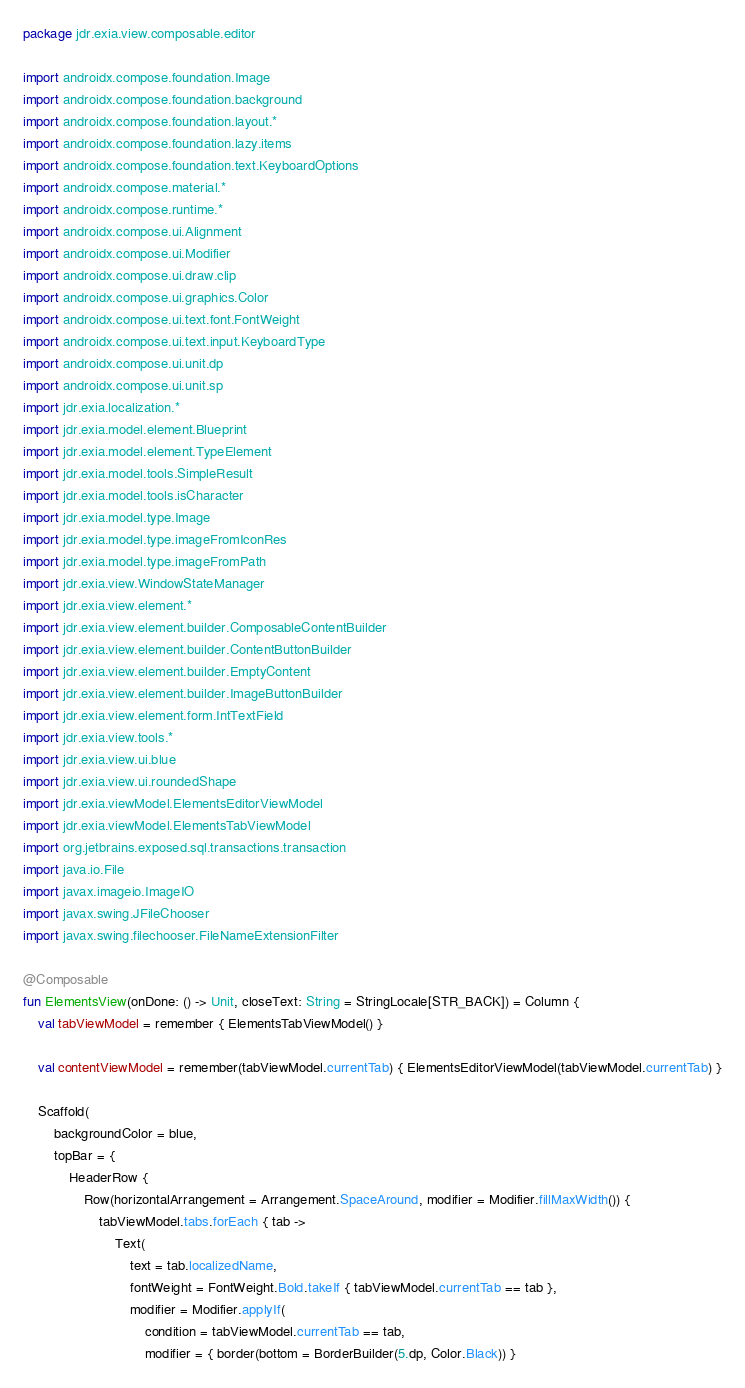<code> <loc_0><loc_0><loc_500><loc_500><_Kotlin_>package jdr.exia.view.composable.editor

import androidx.compose.foundation.Image
import androidx.compose.foundation.background
import androidx.compose.foundation.layout.*
import androidx.compose.foundation.lazy.items
import androidx.compose.foundation.text.KeyboardOptions
import androidx.compose.material.*
import androidx.compose.runtime.*
import androidx.compose.ui.Alignment
import androidx.compose.ui.Modifier
import androidx.compose.ui.draw.clip
import androidx.compose.ui.graphics.Color
import androidx.compose.ui.text.font.FontWeight
import androidx.compose.ui.text.input.KeyboardType
import androidx.compose.ui.unit.dp
import androidx.compose.ui.unit.sp
import jdr.exia.localization.*
import jdr.exia.model.element.Blueprint
import jdr.exia.model.element.TypeElement
import jdr.exia.model.tools.SimpleResult
import jdr.exia.model.tools.isCharacter
import jdr.exia.model.type.Image
import jdr.exia.model.type.imageFromIconRes
import jdr.exia.model.type.imageFromPath
import jdr.exia.view.WindowStateManager
import jdr.exia.view.element.*
import jdr.exia.view.element.builder.ComposableContentBuilder
import jdr.exia.view.element.builder.ContentButtonBuilder
import jdr.exia.view.element.builder.EmptyContent
import jdr.exia.view.element.builder.ImageButtonBuilder
import jdr.exia.view.element.form.IntTextField
import jdr.exia.view.tools.*
import jdr.exia.view.ui.blue
import jdr.exia.view.ui.roundedShape
import jdr.exia.viewModel.ElementsEditorViewModel
import jdr.exia.viewModel.ElementsTabViewModel
import org.jetbrains.exposed.sql.transactions.transaction
import java.io.File
import javax.imageio.ImageIO
import javax.swing.JFileChooser
import javax.swing.filechooser.FileNameExtensionFilter

@Composable
fun ElementsView(onDone: () -> Unit, closeText: String = StringLocale[STR_BACK]) = Column {
    val tabViewModel = remember { ElementsTabViewModel() }

    val contentViewModel = remember(tabViewModel.currentTab) { ElementsEditorViewModel(tabViewModel.currentTab) }

    Scaffold(
        backgroundColor = blue,
        topBar = {
            HeaderRow {
                Row(horizontalArrangement = Arrangement.SpaceAround, modifier = Modifier.fillMaxWidth()) {
                    tabViewModel.tabs.forEach { tab ->
                        Text(
                            text = tab.localizedName,
                            fontWeight = FontWeight.Bold.takeIf { tabViewModel.currentTab == tab },
                            modifier = Modifier.applyIf(
                                condition = tabViewModel.currentTab == tab,
                                modifier = { border(bottom = BorderBuilder(5.dp, Color.Black)) }</code> 